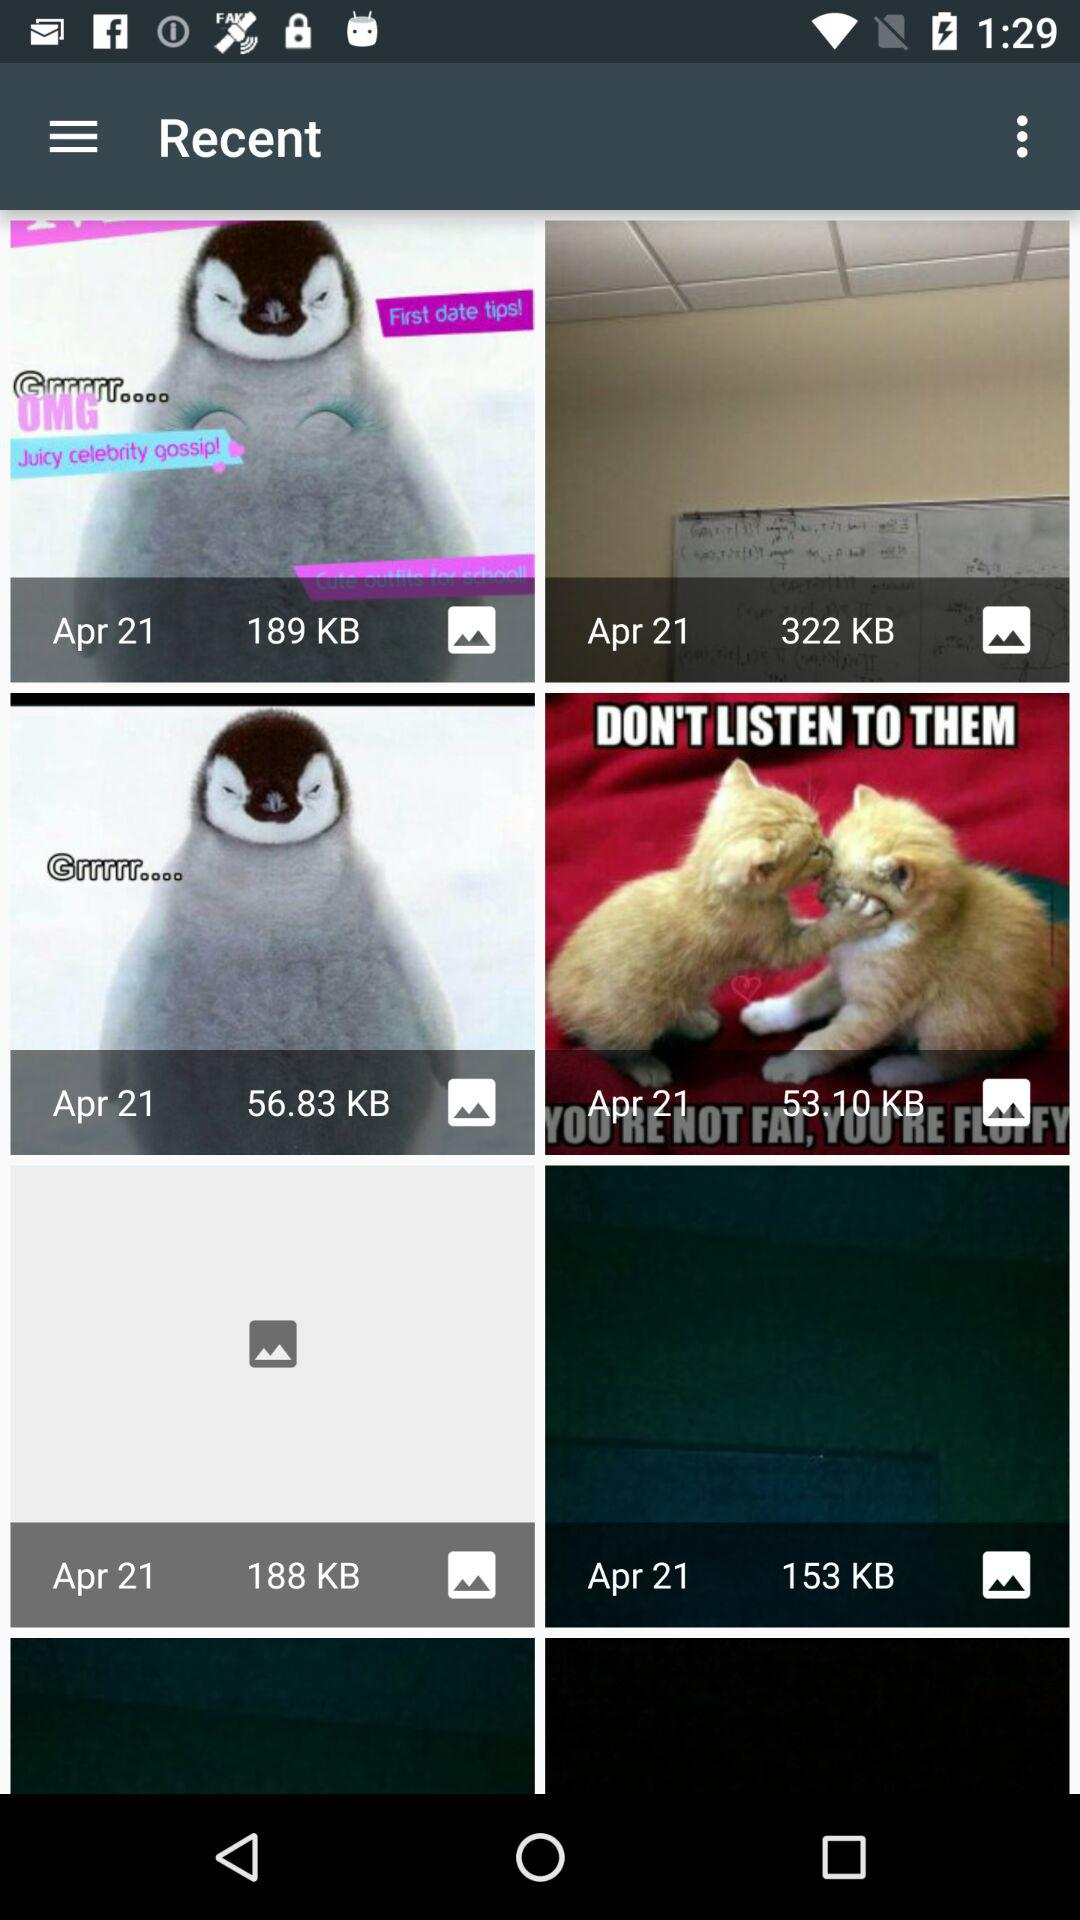When was the last image update?
When the provided information is insufficient, respond with <no answer>. <no answer> 